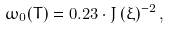Convert formula to latex. <formula><loc_0><loc_0><loc_500><loc_500>\omega _ { 0 } ( T ) = 0 . 2 3 \cdot J \, ( \xi ) ^ { - 2 } \, , \,</formula> 